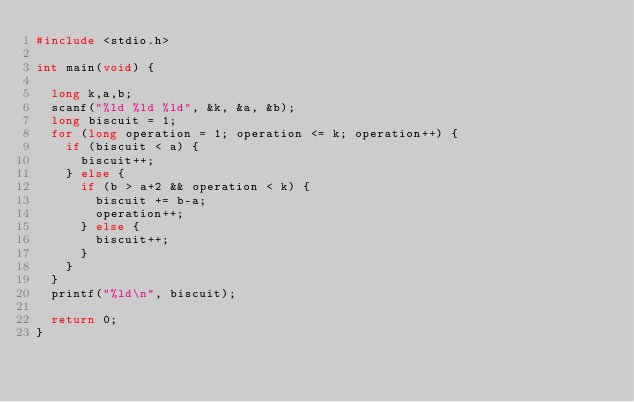Convert code to text. <code><loc_0><loc_0><loc_500><loc_500><_C_>#include <stdio.h>

int main(void) {

  long k,a,b;
  scanf("%ld %ld %ld", &k, &a, &b);
  long biscuit = 1;
  for (long operation = 1; operation <= k; operation++) {
    if (biscuit < a) {
      biscuit++;
    } else {
      if (b > a+2 && operation < k) {
        biscuit += b-a;
        operation++;
      } else {
        biscuit++;
      }
    }
  }
  printf("%ld\n", biscuit);

  return 0;
}</code> 